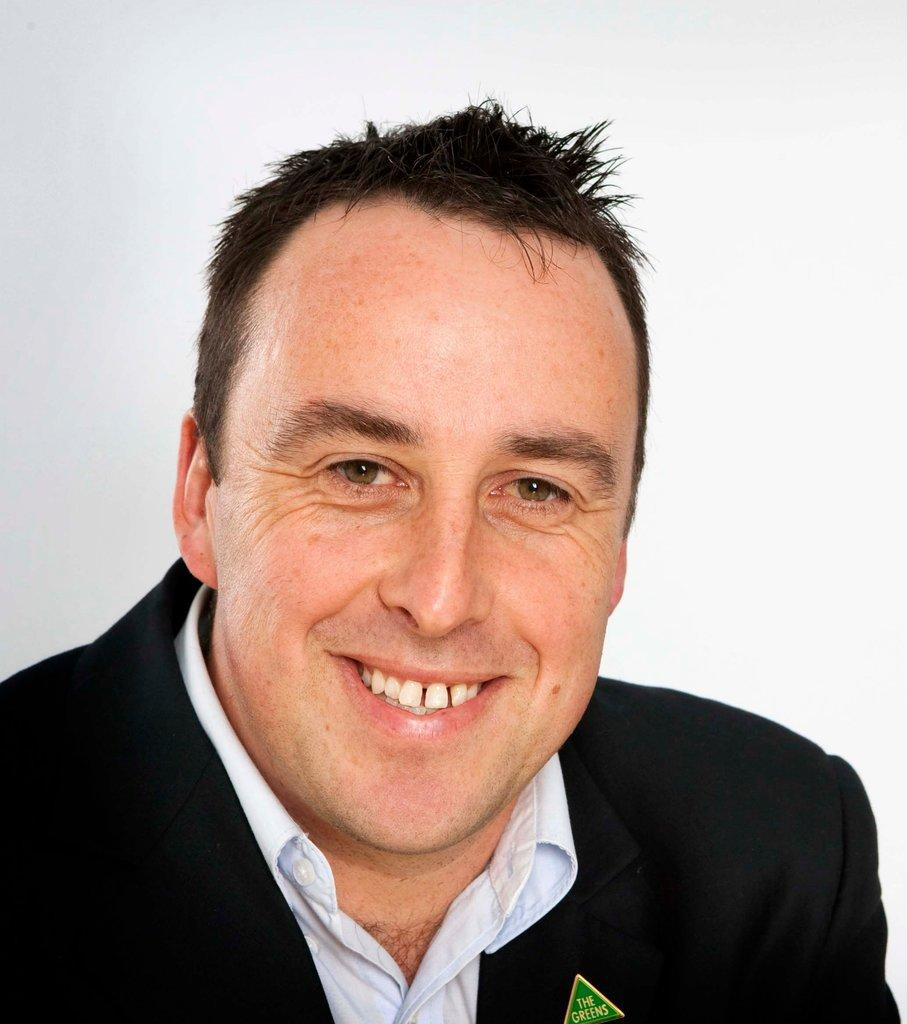What is the main subject in the foreground of the image? There is a man in the foreground of the image. What can be seen in the background of the image? The background of the image is white. How many beds are visible in the image? There are no beds present in the image. What type of ship can be seen sailing in the background? There is no ship visible in the image, as the background is white. 